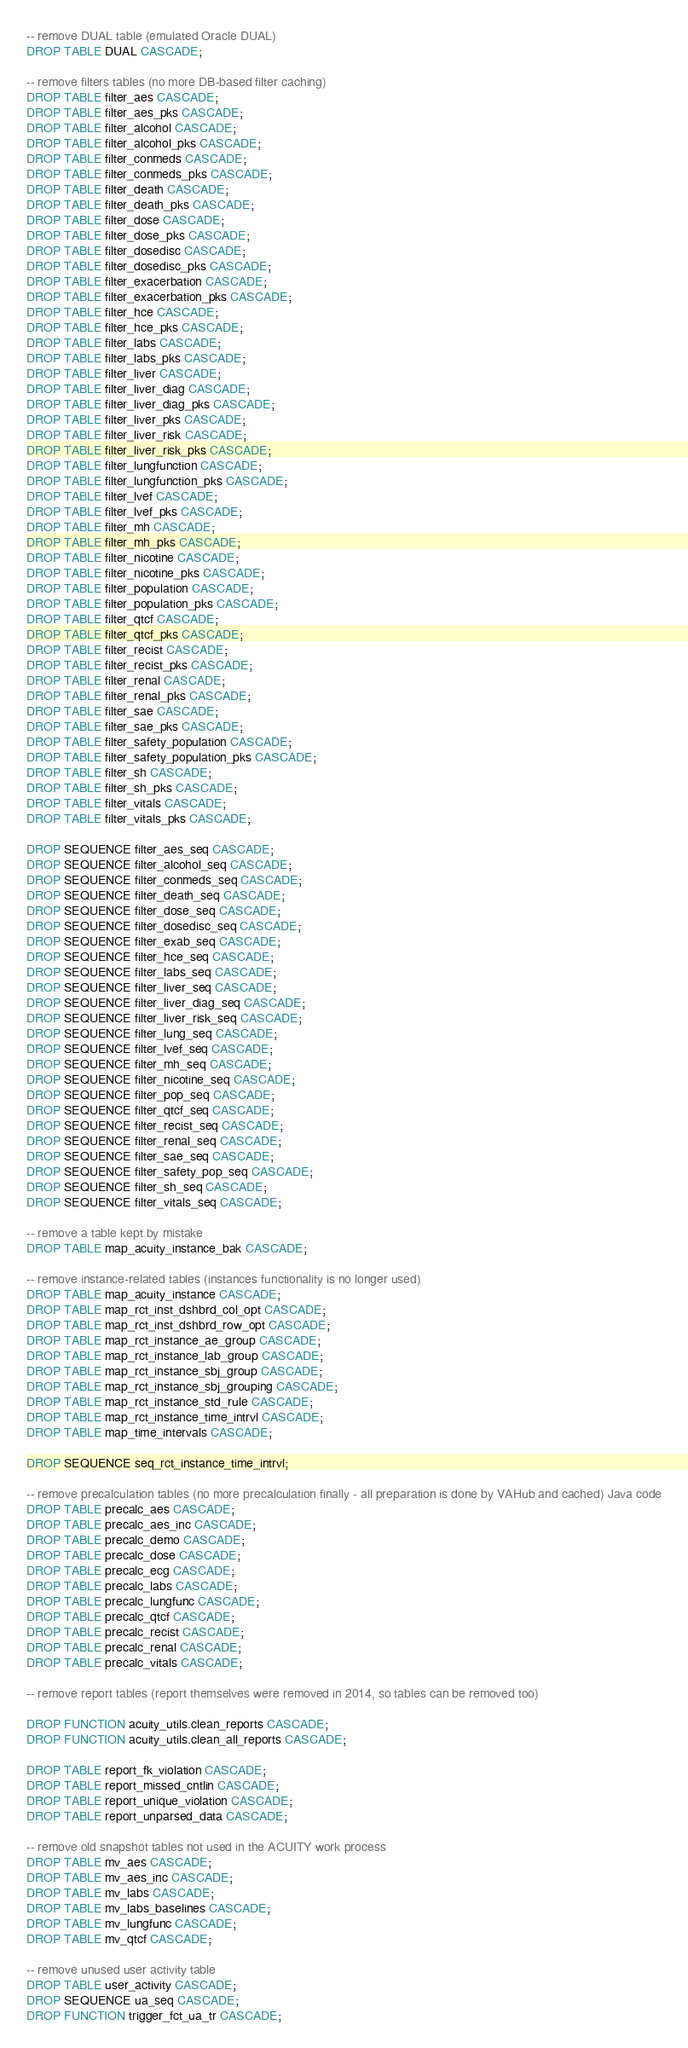Convert code to text. <code><loc_0><loc_0><loc_500><loc_500><_SQL_>-- remove DUAL table (emulated Oracle DUAL)
DROP TABLE DUAL CASCADE;

-- remove filters tables (no more DB-based filter caching)
DROP TABLE filter_aes CASCADE;
DROP TABLE filter_aes_pks CASCADE;
DROP TABLE filter_alcohol CASCADE;
DROP TABLE filter_alcohol_pks CASCADE;
DROP TABLE filter_conmeds CASCADE;
DROP TABLE filter_conmeds_pks CASCADE;
DROP TABLE filter_death CASCADE;
DROP TABLE filter_death_pks CASCADE;
DROP TABLE filter_dose CASCADE;
DROP TABLE filter_dose_pks CASCADE;
DROP TABLE filter_dosedisc CASCADE;
DROP TABLE filter_dosedisc_pks CASCADE;
DROP TABLE filter_exacerbation CASCADE;
DROP TABLE filter_exacerbation_pks CASCADE;
DROP TABLE filter_hce CASCADE;
DROP TABLE filter_hce_pks CASCADE;
DROP TABLE filter_labs CASCADE;
DROP TABLE filter_labs_pks CASCADE;
DROP TABLE filter_liver CASCADE;
DROP TABLE filter_liver_diag CASCADE;
DROP TABLE filter_liver_diag_pks CASCADE;
DROP TABLE filter_liver_pks CASCADE;
DROP TABLE filter_liver_risk CASCADE;
DROP TABLE filter_liver_risk_pks CASCADE;
DROP TABLE filter_lungfunction CASCADE;
DROP TABLE filter_lungfunction_pks CASCADE;
DROP TABLE filter_lvef CASCADE;
DROP TABLE filter_lvef_pks CASCADE;
DROP TABLE filter_mh CASCADE;
DROP TABLE filter_mh_pks CASCADE;
DROP TABLE filter_nicotine CASCADE;
DROP TABLE filter_nicotine_pks CASCADE;
DROP TABLE filter_population CASCADE;
DROP TABLE filter_population_pks CASCADE;
DROP TABLE filter_qtcf CASCADE;
DROP TABLE filter_qtcf_pks CASCADE;
DROP TABLE filter_recist CASCADE;
DROP TABLE filter_recist_pks CASCADE;
DROP TABLE filter_renal CASCADE;
DROP TABLE filter_renal_pks CASCADE;
DROP TABLE filter_sae CASCADE;
DROP TABLE filter_sae_pks CASCADE;
DROP TABLE filter_safety_population CASCADE;
DROP TABLE filter_safety_population_pks CASCADE;
DROP TABLE filter_sh CASCADE;
DROP TABLE filter_sh_pks CASCADE;
DROP TABLE filter_vitals CASCADE;
DROP TABLE filter_vitals_pks CASCADE;

DROP SEQUENCE filter_aes_seq CASCADE;
DROP SEQUENCE filter_alcohol_seq CASCADE;
DROP SEQUENCE filter_conmeds_seq CASCADE;
DROP SEQUENCE filter_death_seq CASCADE;
DROP SEQUENCE filter_dose_seq CASCADE;
DROP SEQUENCE filter_dosedisc_seq CASCADE;
DROP SEQUENCE filter_exab_seq CASCADE;
DROP SEQUENCE filter_hce_seq CASCADE;
DROP SEQUENCE filter_labs_seq CASCADE;
DROP SEQUENCE filter_liver_seq CASCADE;
DROP SEQUENCE filter_liver_diag_seq CASCADE;
DROP SEQUENCE filter_liver_risk_seq CASCADE;
DROP SEQUENCE filter_lung_seq CASCADE;
DROP SEQUENCE filter_lvef_seq CASCADE;
DROP SEQUENCE filter_mh_seq CASCADE;
DROP SEQUENCE filter_nicotine_seq CASCADE;
DROP SEQUENCE filter_pop_seq CASCADE;
DROP SEQUENCE filter_qtcf_seq CASCADE;
DROP SEQUENCE filter_recist_seq CASCADE;
DROP SEQUENCE filter_renal_seq CASCADE;
DROP SEQUENCE filter_sae_seq CASCADE;
DROP SEQUENCE filter_safety_pop_seq CASCADE;
DROP SEQUENCE filter_sh_seq CASCADE;
DROP SEQUENCE filter_vitals_seq CASCADE;

-- remove a table kept by mistake
DROP TABLE map_acuity_instance_bak CASCADE;

-- remove instance-related tables (instances functionality is no longer used)
DROP TABLE map_acuity_instance CASCADE;
DROP TABLE map_rct_inst_dshbrd_col_opt CASCADE;
DROP TABLE map_rct_inst_dshbrd_row_opt CASCADE;
DROP TABLE map_rct_instance_ae_group CASCADE;
DROP TABLE map_rct_instance_lab_group CASCADE;
DROP TABLE map_rct_instance_sbj_group CASCADE;
DROP TABLE map_rct_instance_sbj_grouping CASCADE;
DROP TABLE map_rct_instance_std_rule CASCADE;
DROP TABLE map_rct_instance_time_intrvl CASCADE;
DROP TABLE map_time_intervals CASCADE;

DROP SEQUENCE seq_rct_instance_time_intrvl;

-- remove precalculation tables (no more precalculation finally - all preparation is done by VAHub and cached) Java code
DROP TABLE precalc_aes CASCADE;
DROP TABLE precalc_aes_inc CASCADE;
DROP TABLE precalc_demo CASCADE;
DROP TABLE precalc_dose CASCADE;
DROP TABLE precalc_ecg CASCADE;
DROP TABLE precalc_labs CASCADE;
DROP TABLE precalc_lungfunc CASCADE;
DROP TABLE precalc_qtcf CASCADE;
DROP TABLE precalc_recist CASCADE;
DROP TABLE precalc_renal CASCADE;
DROP TABLE precalc_vitals CASCADE;

-- remove report tables (report themselves were removed in 2014, so tables can be removed too)

DROP FUNCTION acuity_utils.clean_reports CASCADE;
DROP FUNCTION acuity_utils.clean_all_reports CASCADE;

DROP TABLE report_fk_violation CASCADE;
DROP TABLE report_missed_cntlin CASCADE;
DROP TABLE report_unique_violation CASCADE;
DROP TABLE report_unparsed_data CASCADE;

-- remove old snapshot tables not used in the ACUITY work process
DROP TABLE mv_aes CASCADE;
DROP TABLE mv_aes_inc CASCADE;
DROP TABLE mv_labs CASCADE;
DROP TABLE mv_labs_baselines CASCADE;
DROP TABLE mv_lungfunc CASCADE;
DROP TABLE mv_qtcf CASCADE;

-- remove unused user activity table
DROP TABLE user_activity CASCADE;
DROP SEQUENCE ua_seq CASCADE;
DROP FUNCTION trigger_fct_ua_tr CASCADE;
</code> 